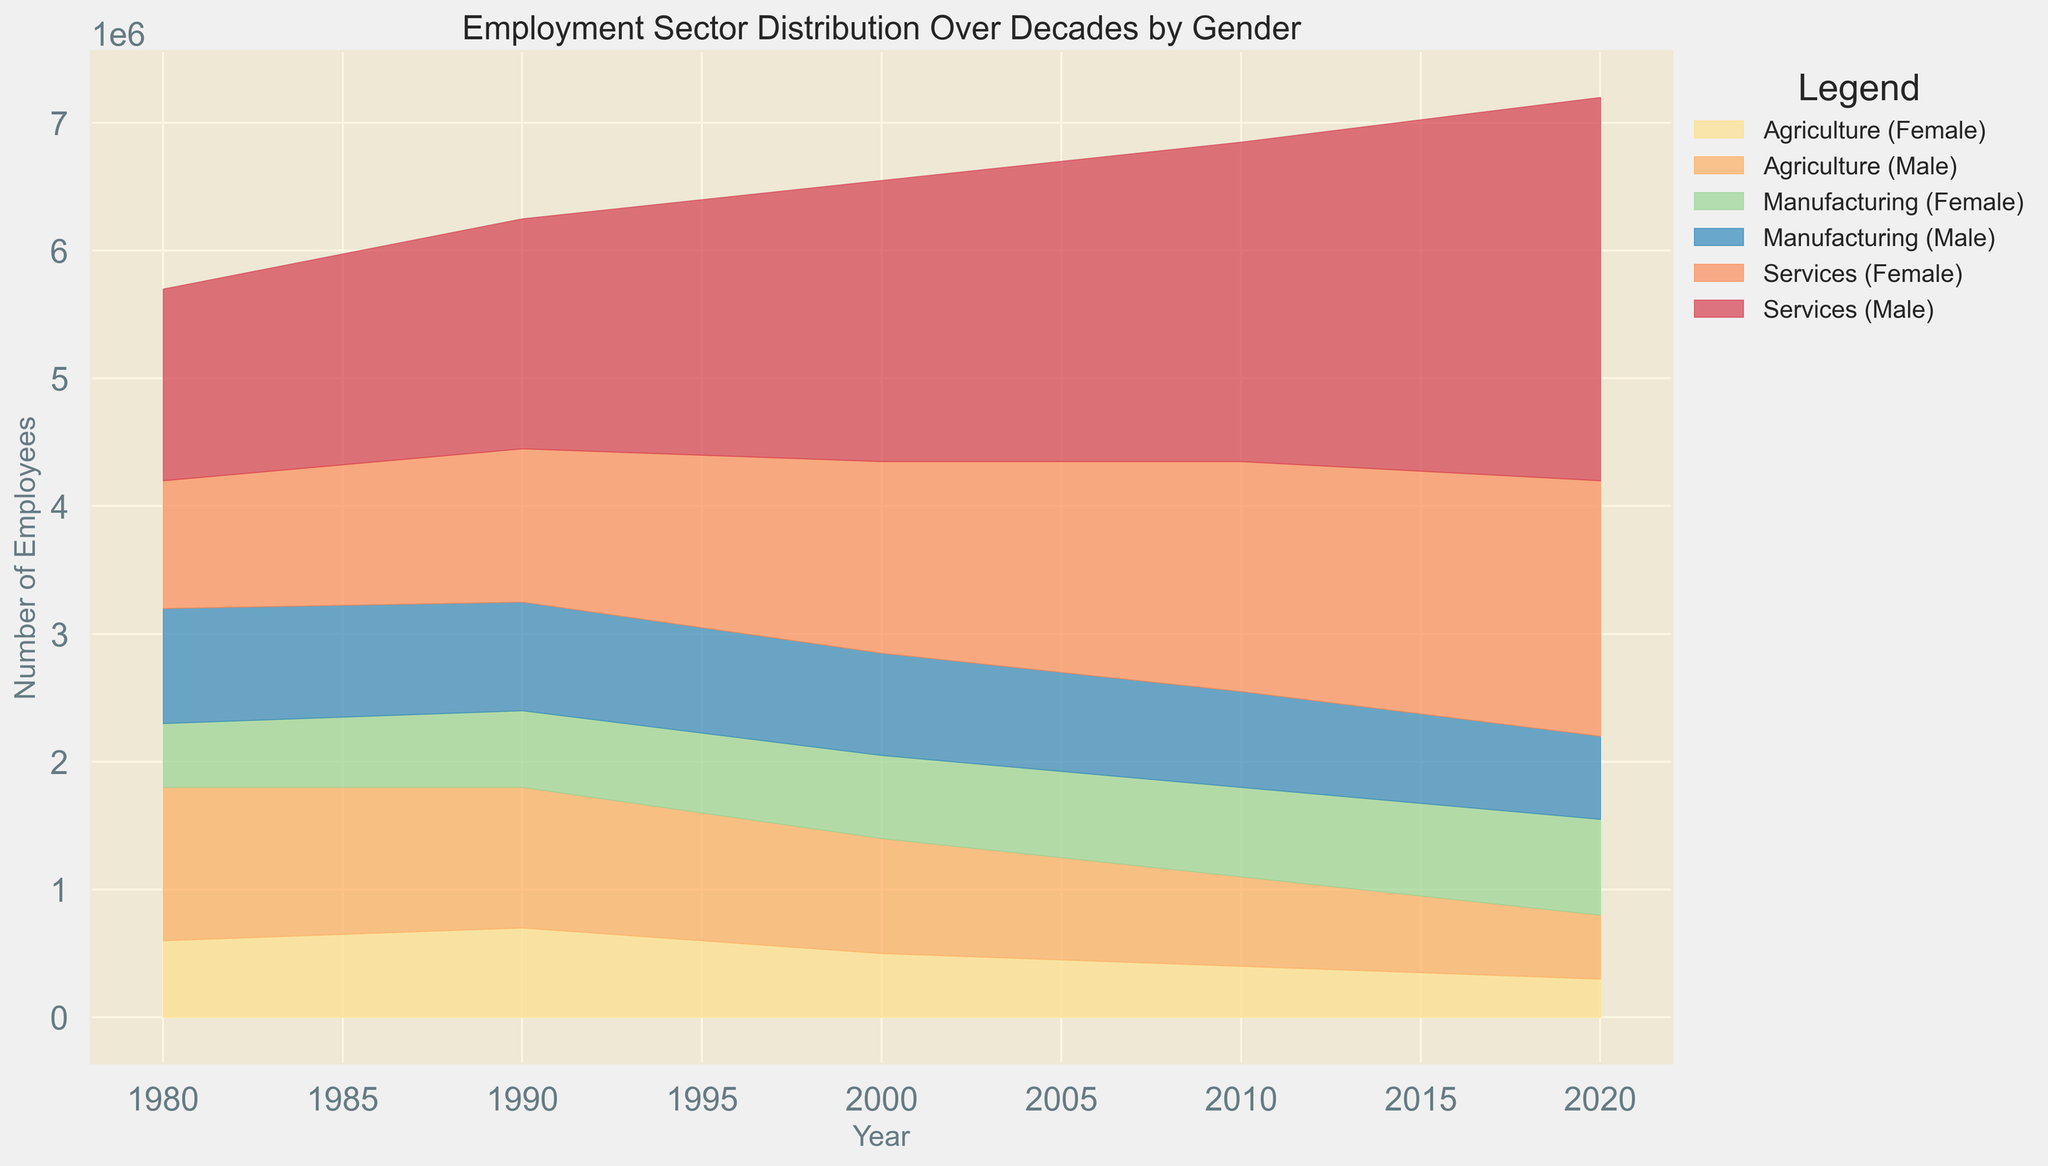Which sector had the highest number of employees in 2020? By observing the area chart, the sector with the highest peak in 2020 can be identified. The Services sector has the largest area at the top for both males and females combined compared to other sectors.
Answer: Services How did female employment in Agriculture change from 1980 to 2020? Look at the area representing female employment in Agriculture over time and compare its height from 1980 to 2020. Female employment in Agriculture decreased from 600,000 in 1980 to 300,000 in 2020.
Answer: Decreased Between 2010 and 2020, which sector saw the most significant increase in female employment? By examining the area chart for the female sections between 2010 and 2020, observe which sector's area increased the most. Manufacturing showed the most increase, from 700,000 to 750,000.
Answer: Manufacturing Compare male employment in Manufacturing and Services sectors in 2000. Which sector had more male employees? Observe the height of the areas representing male employment in both sectors for the year 2000. The Services sector had 2,200,000 male employees, while Manufacturing had 800,000.
Answer: Services In which decade did male employment in Agriculture decrease the most significantly? Compare the drop in the area representing male employment in Agriculture across each decade. The biggest decrease seems to happen between 2000 and 2010. The number went from 900,000 to 700,000, which is a 200,000 drop.
Answer: 2000-2010 What is the total number of employees in the Services sector in 2010, across both genders? Sum the male and female areas for the Services sector in 2010: 2,500,000 (male) + 1,800,000 (female) = 4,300,000.
Answer: 4,300,000 How has the gender distribution in Manufacturing changed from 1980 to 2020? Compare the areas representing male and female employees in Manufacturing from 1980 to 2020. In 1980, there were more males (900,000 vs. 500,000). By 2020, female employees outnumbered male employees (750,000 vs. 650,000).
Answer: Females increased more By how much did total employment in Agriculture decrease from 1980 to 2020? Sum male and female employment in Agriculture for each year and find the difference. In 1980: 1,200,000 (male) + 600,000 (female) = 1,800,000. In 2020: 500,000 (male) + 300,000 (female) = 800,000. 1,800,000 - 800,000 = 1,000,000.
Answer: 1,000,000 When did total employment in the Services sector first exceed 3,000,000? Sum the male and female areas for the Services sector across the years and find when the total first exceeds 3,000,000. In 1990, the total was 1,800,000 (male) + 1,200,000 (female) = 3,000,000 exactly.
Answer: 1990 How much did male employment in Services increase from 1980 to 2020? Subtract the number of male employees in Services in 1980 from that in 2020. 3,000,000 (2020) - 1,500,000 (1980) = 1,500,000.
Answer: 1,500,000 